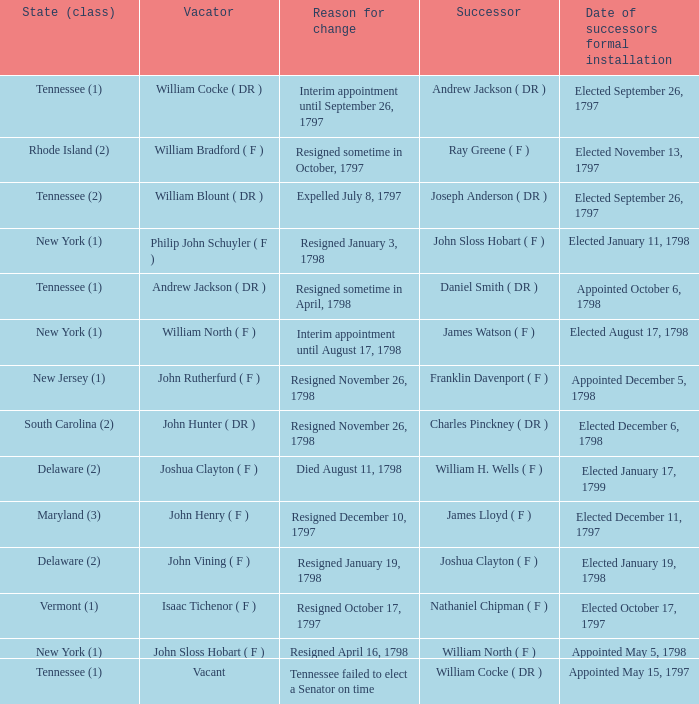Could you parse the entire table? {'header': ['State (class)', 'Vacator', 'Reason for change', 'Successor', 'Date of successors formal installation'], 'rows': [['Tennessee (1)', 'William Cocke ( DR )', 'Interim appointment until September 26, 1797', 'Andrew Jackson ( DR )', 'Elected September 26, 1797'], ['Rhode Island (2)', 'William Bradford ( F )', 'Resigned sometime in October, 1797', 'Ray Greene ( F )', 'Elected November 13, 1797'], ['Tennessee (2)', 'William Blount ( DR )', 'Expelled July 8, 1797', 'Joseph Anderson ( DR )', 'Elected September 26, 1797'], ['New York (1)', 'Philip John Schuyler ( F )', 'Resigned January 3, 1798', 'John Sloss Hobart ( F )', 'Elected January 11, 1798'], ['Tennessee (1)', 'Andrew Jackson ( DR )', 'Resigned sometime in April, 1798', 'Daniel Smith ( DR )', 'Appointed October 6, 1798'], ['New York (1)', 'William North ( F )', 'Interim appointment until August 17, 1798', 'James Watson ( F )', 'Elected August 17, 1798'], ['New Jersey (1)', 'John Rutherfurd ( F )', 'Resigned November 26, 1798', 'Franklin Davenport ( F )', 'Appointed December 5, 1798'], ['South Carolina (2)', 'John Hunter ( DR )', 'Resigned November 26, 1798', 'Charles Pinckney ( DR )', 'Elected December 6, 1798'], ['Delaware (2)', 'Joshua Clayton ( F )', 'Died August 11, 1798', 'William H. Wells ( F )', 'Elected January 17, 1799'], ['Maryland (3)', 'John Henry ( F )', 'Resigned December 10, 1797', 'James Lloyd ( F )', 'Elected December 11, 1797'], ['Delaware (2)', 'John Vining ( F )', 'Resigned January 19, 1798', 'Joshua Clayton ( F )', 'Elected January 19, 1798'], ['Vermont (1)', 'Isaac Tichenor ( F )', 'Resigned October 17, 1797', 'Nathaniel Chipman ( F )', 'Elected October 17, 1797'], ['New York (1)', 'John Sloss Hobart ( F )', 'Resigned April 16, 1798', 'William North ( F )', 'Appointed May 5, 1798'], ['Tennessee (1)', 'Vacant', 'Tennessee failed to elect a Senator on time', 'William Cocke ( DR )', 'Appointed May 15, 1797']]} What is the total number of dates of successor formal installation when the vacator was Joshua Clayton ( F )? 1.0. 